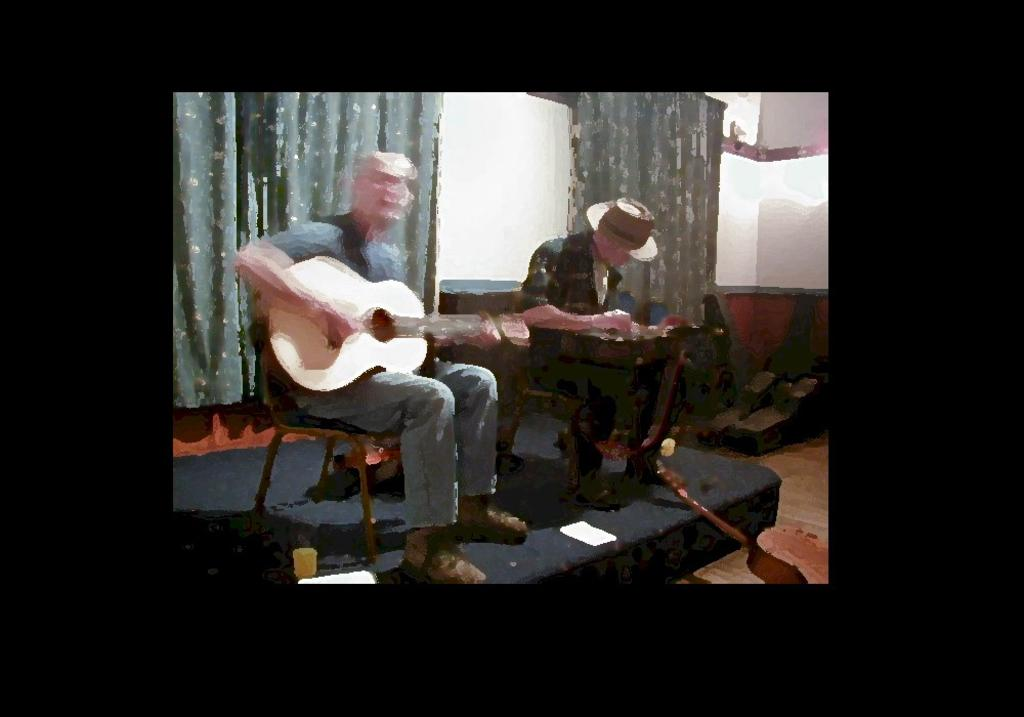How many people are present in the image? There are two people in the image. What are the two people doing in the image? The two people are sitting and playing a guitar. What can be seen in the background of the image? There is a curtain in the background of the image. What health benefits does the hole in the image provide? There is no hole present in the image, so it cannot provide any health benefits. 